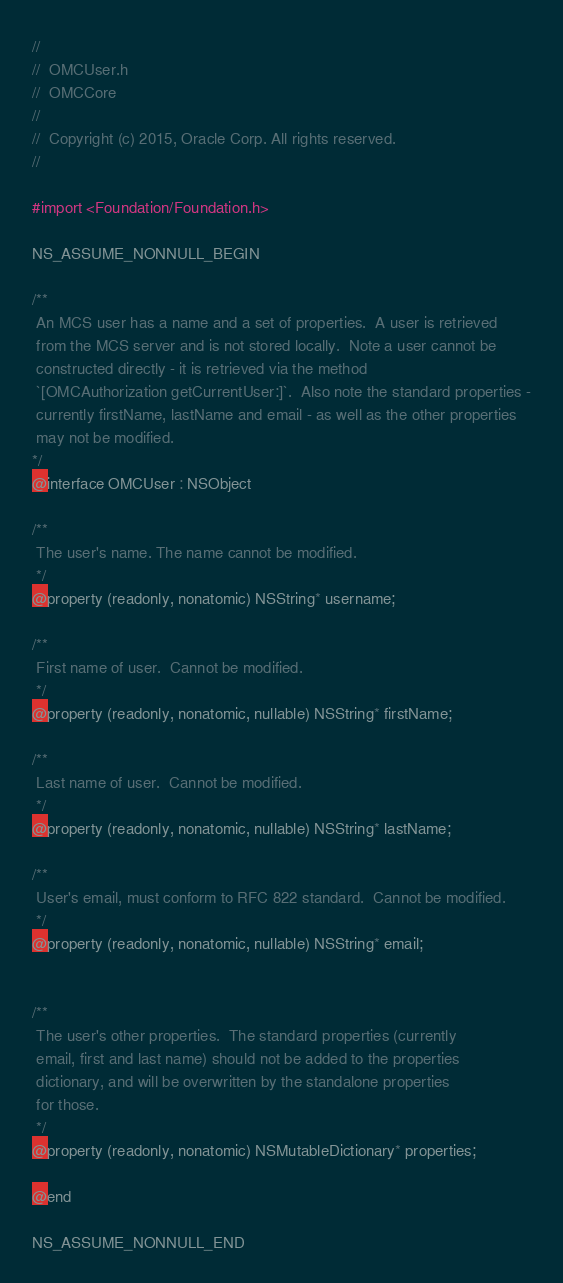<code> <loc_0><loc_0><loc_500><loc_500><_C_>//
//  OMCUser.h
//  OMCCore
//
//  Copyright (c) 2015, Oracle Corp. All rights reserved. 
//

#import <Foundation/Foundation.h>

NS_ASSUME_NONNULL_BEGIN

/**
 An MCS user has a name and a set of properties.  A user is retrieved
 from the MCS server and is not stored locally.  Note a user cannot be
 constructed directly - it is retrieved via the method
 `[OMCAuthorization getCurrentUser:]`.  Also note the standard properties -
 currently firstName, lastName and email - as well as the other properties
 may not be modified.
*/
@interface OMCUser : NSObject

/**
 The user's name. The name cannot be modified.
 */
@property (readonly, nonatomic) NSString* username;

/**
 First name of user.  Cannot be modified.
 */
@property (readonly, nonatomic, nullable) NSString* firstName;

/**
 Last name of user.  Cannot be modified.
 */
@property (readonly, nonatomic, nullable) NSString* lastName;

/**
 User's email, must conform to RFC 822 standard.  Cannot be modified.
 */
@property (readonly, nonatomic, nullable) NSString* email;


/**
 The user's other properties.  The standard properties (currently
 email, first and last name) should not be added to the properties
 dictionary, and will be overwritten by the standalone properties
 for those.
 */
@property (readonly, nonatomic) NSMutableDictionary* properties;

@end

NS_ASSUME_NONNULL_END
</code> 